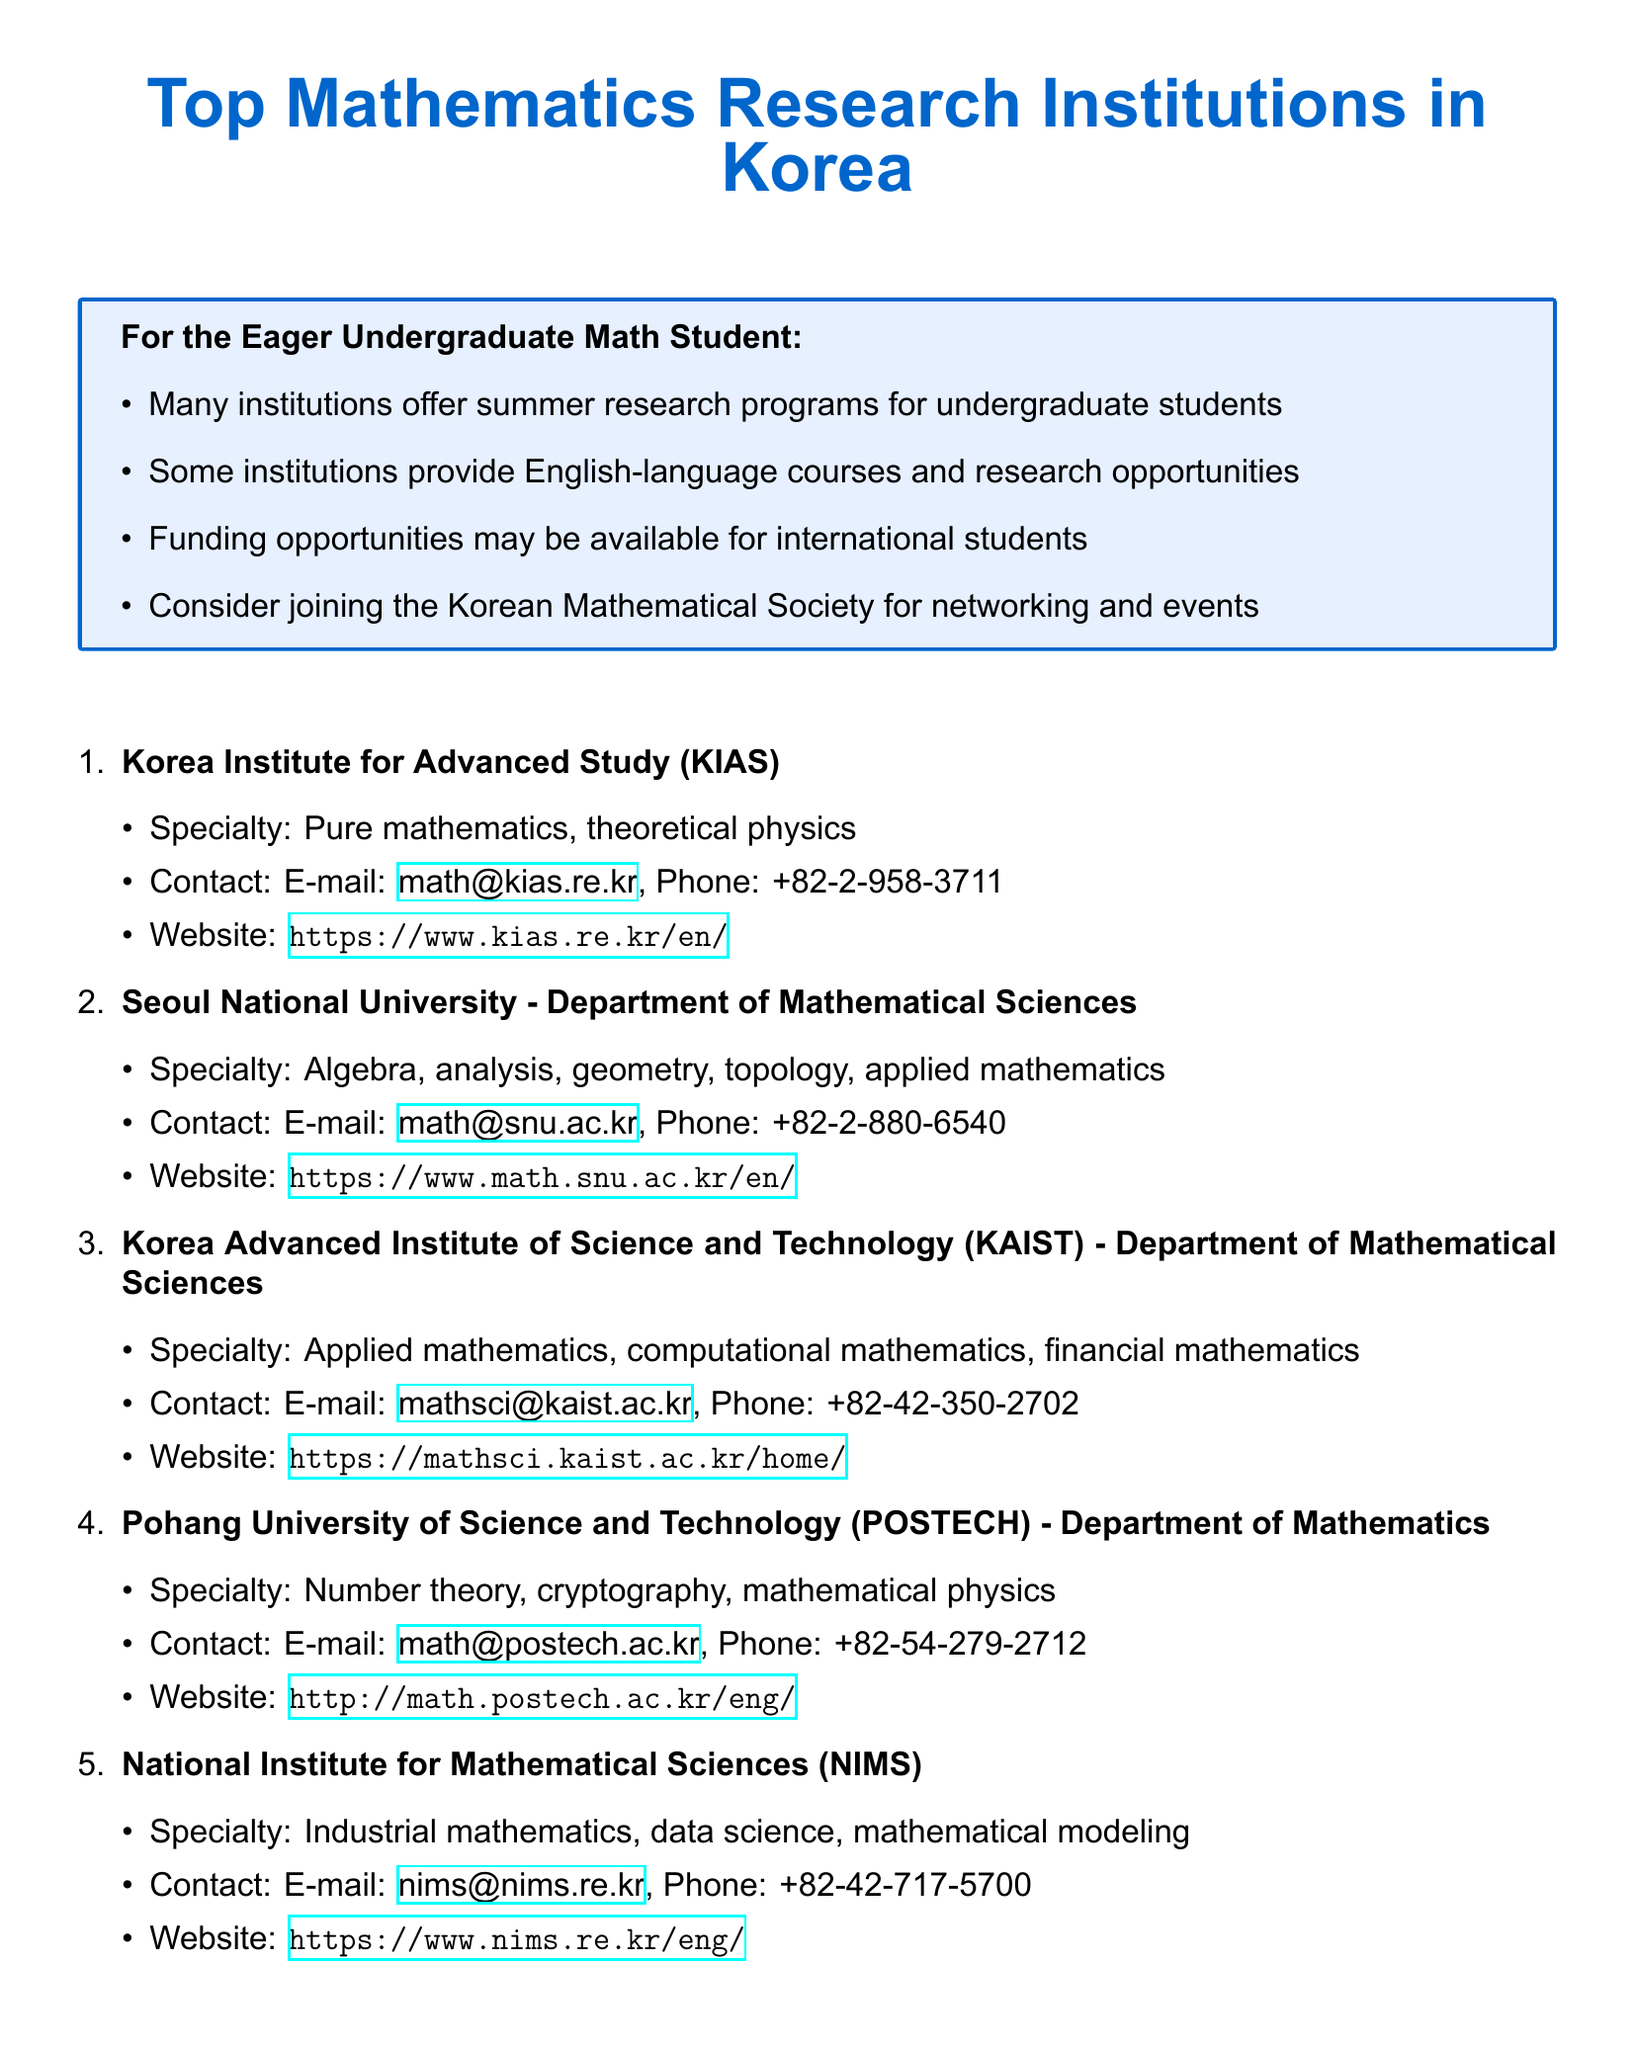What is the specialty of KIAS? The specialty listed for KIAS is Pure mathematics, theoretical physics.
Answer: Pure mathematics, theoretical physics What is the contact email for POSTECH? The contact email for POSTECH is provided in the document as math@postech.ac.kr.
Answer: math@postech.ac.kr Which institution specializes in industrial mathematics? The institution that specializes in industrial mathematics is mentioned as NIMS.
Answer: NIMS How many institutions are listed in the document? The document lists a total of five mathematics research institutions in Korea.
Answer: Five What additional information is provided for undergraduate students? The document mentions that many institutions offer summer research programs for undergraduate students.
Answer: Summer research programs Which university is located in Seoul? The university located in Seoul is Seoul National University.
Answer: Seoul National University What is the phone number for KAIST? The phone number for KAIST is listed as +82-42-350-2702.
Answer: +82-42-350-2702 Which institution focuses on applied mathematics, computational mathematics, and financial mathematics? The institution that focuses on these areas is KAIST.
Answer: KAIST What should students consider joining for networking? The document suggests considering joining the Korean Mathematical Society for networking and events.
Answer: Korean Mathematical Society 